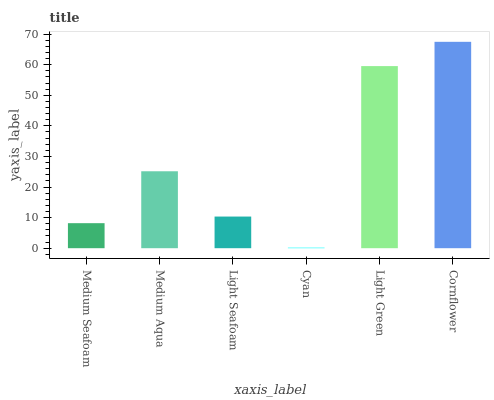Is Cyan the minimum?
Answer yes or no. Yes. Is Cornflower the maximum?
Answer yes or no. Yes. Is Medium Aqua the minimum?
Answer yes or no. No. Is Medium Aqua the maximum?
Answer yes or no. No. Is Medium Aqua greater than Medium Seafoam?
Answer yes or no. Yes. Is Medium Seafoam less than Medium Aqua?
Answer yes or no. Yes. Is Medium Seafoam greater than Medium Aqua?
Answer yes or no. No. Is Medium Aqua less than Medium Seafoam?
Answer yes or no. No. Is Medium Aqua the high median?
Answer yes or no. Yes. Is Light Seafoam the low median?
Answer yes or no. Yes. Is Cornflower the high median?
Answer yes or no. No. Is Light Green the low median?
Answer yes or no. No. 